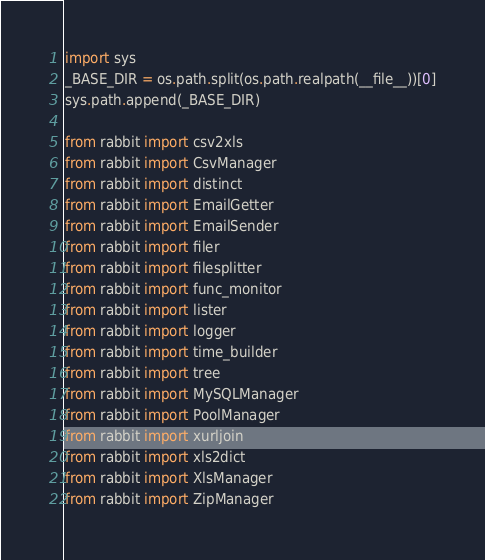<code> <loc_0><loc_0><loc_500><loc_500><_Python_>import sys
_BASE_DIR = os.path.split(os.path.realpath(__file__))[0]
sys.path.append(_BASE_DIR)

from rabbit import csv2xls
from rabbit import CsvManager
from rabbit import distinct
from rabbit import EmailGetter
from rabbit import EmailSender
from rabbit import filer
from rabbit import filesplitter
from rabbit import func_monitor
from rabbit import lister
from rabbit import logger
from rabbit import time_builder
from rabbit import tree
from rabbit import MySQLManager
from rabbit import PoolManager
from rabbit import xurljoin
from rabbit import xls2dict
from rabbit import XlsManager
from rabbit import ZipManager
</code> 